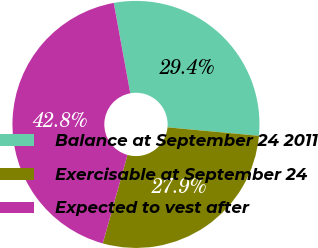Convert chart. <chart><loc_0><loc_0><loc_500><loc_500><pie_chart><fcel>Balance at September 24 2011<fcel>Exercisable at September 24<fcel>Expected to vest after<nl><fcel>29.35%<fcel>27.86%<fcel>42.79%<nl></chart> 